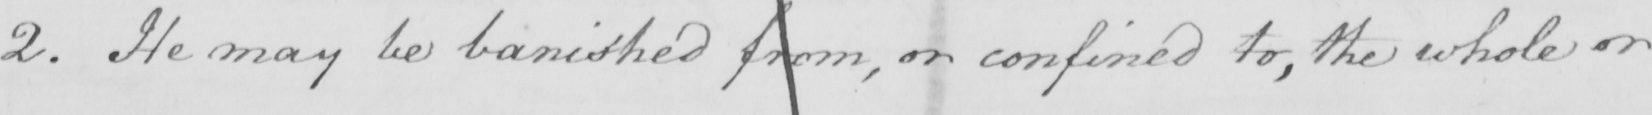What is written in this line of handwriting? 2 . He may be banished from , or confined to , the whole or 